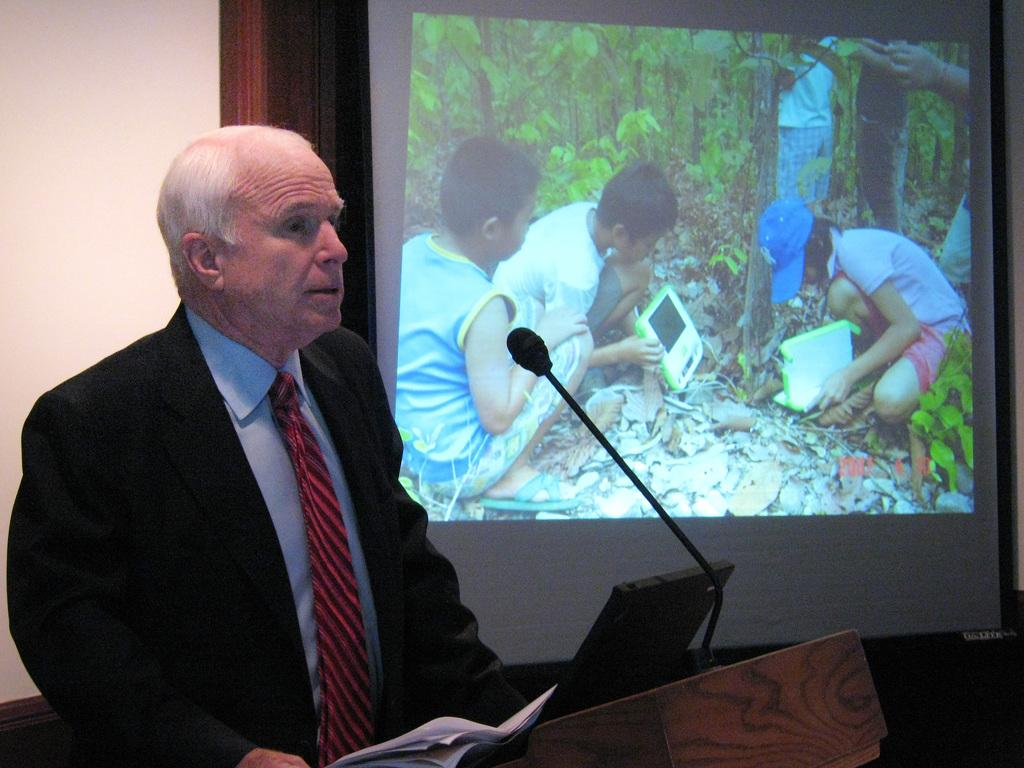Who is present in the image? There is a man in the image. What is the man wearing? The man is wearing a suit. What object can be seen near the man? There is a microphone in the image. What items are on the table in the image? There are papers and a screen in the image. What can be seen at the back of the room? There is a projector display at the back of the room. Can you see any markets or people jumping in the image? No, there are no markets or people jumping in the image. Is there a balloon visible in the image? No, there is no balloon present in the image. 